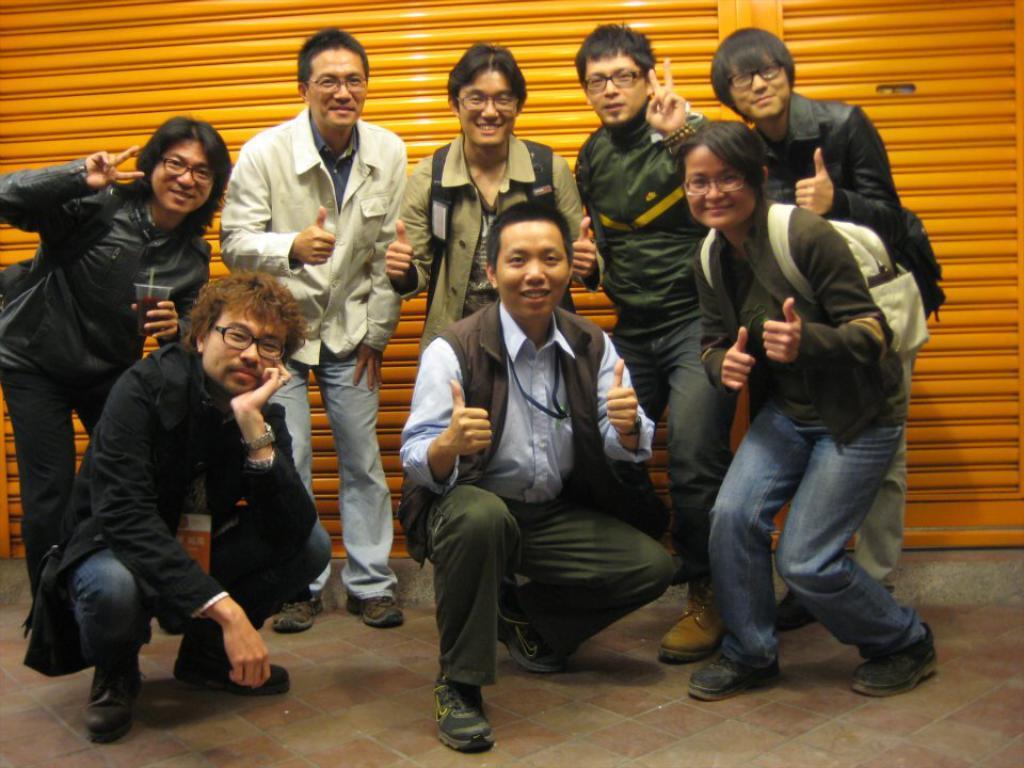Could you give a brief overview of what you see in this image? In this picture I can see a group of people in the middle, in the background there are shutters. 